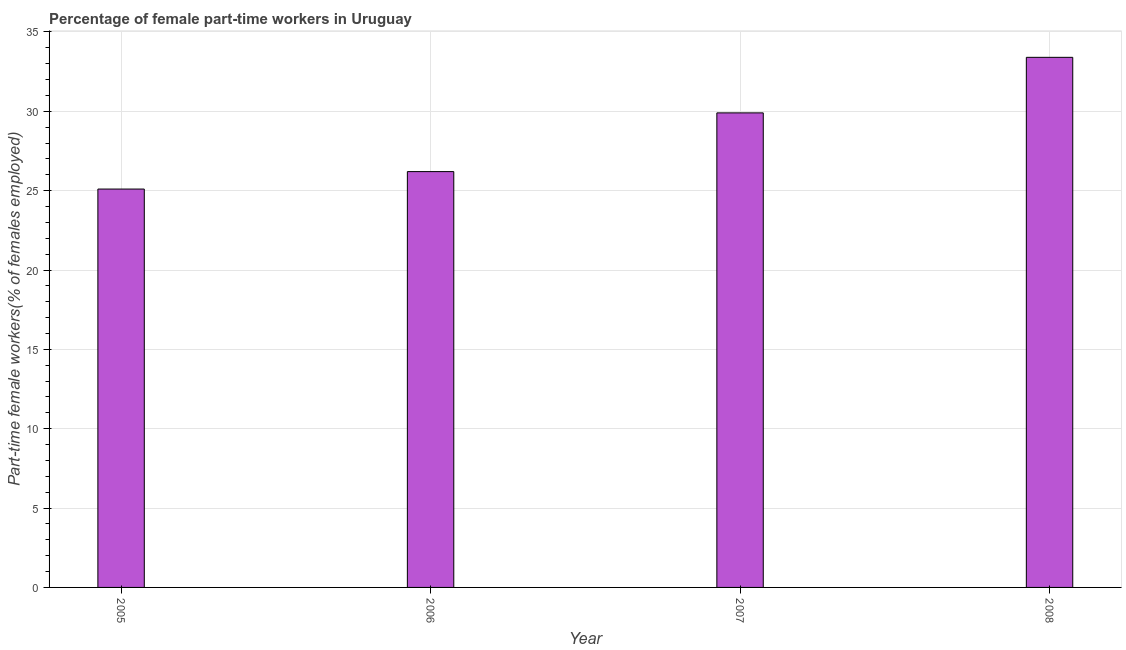What is the title of the graph?
Provide a short and direct response. Percentage of female part-time workers in Uruguay. What is the label or title of the X-axis?
Keep it short and to the point. Year. What is the label or title of the Y-axis?
Offer a terse response. Part-time female workers(% of females employed). What is the percentage of part-time female workers in 2005?
Give a very brief answer. 25.1. Across all years, what is the maximum percentage of part-time female workers?
Provide a succinct answer. 33.4. Across all years, what is the minimum percentage of part-time female workers?
Your response must be concise. 25.1. In which year was the percentage of part-time female workers minimum?
Your answer should be compact. 2005. What is the sum of the percentage of part-time female workers?
Give a very brief answer. 114.6. What is the difference between the percentage of part-time female workers in 2006 and 2007?
Offer a terse response. -3.7. What is the average percentage of part-time female workers per year?
Give a very brief answer. 28.65. What is the median percentage of part-time female workers?
Ensure brevity in your answer.  28.05. Do a majority of the years between 2008 and 2007 (inclusive) have percentage of part-time female workers greater than 11 %?
Offer a terse response. No. What is the ratio of the percentage of part-time female workers in 2007 to that in 2008?
Provide a succinct answer. 0.9. Is the percentage of part-time female workers in 2006 less than that in 2008?
Ensure brevity in your answer.  Yes. Is the sum of the percentage of part-time female workers in 2006 and 2007 greater than the maximum percentage of part-time female workers across all years?
Offer a very short reply. Yes. Are all the bars in the graph horizontal?
Keep it short and to the point. No. How many years are there in the graph?
Your answer should be compact. 4. Are the values on the major ticks of Y-axis written in scientific E-notation?
Give a very brief answer. No. What is the Part-time female workers(% of females employed) in 2005?
Give a very brief answer. 25.1. What is the Part-time female workers(% of females employed) of 2006?
Ensure brevity in your answer.  26.2. What is the Part-time female workers(% of females employed) in 2007?
Give a very brief answer. 29.9. What is the Part-time female workers(% of females employed) of 2008?
Your response must be concise. 33.4. What is the difference between the Part-time female workers(% of females employed) in 2006 and 2007?
Give a very brief answer. -3.7. What is the difference between the Part-time female workers(% of females employed) in 2006 and 2008?
Provide a short and direct response. -7.2. What is the ratio of the Part-time female workers(% of females employed) in 2005 to that in 2006?
Give a very brief answer. 0.96. What is the ratio of the Part-time female workers(% of females employed) in 2005 to that in 2007?
Ensure brevity in your answer.  0.84. What is the ratio of the Part-time female workers(% of females employed) in 2005 to that in 2008?
Keep it short and to the point. 0.75. What is the ratio of the Part-time female workers(% of females employed) in 2006 to that in 2007?
Make the answer very short. 0.88. What is the ratio of the Part-time female workers(% of females employed) in 2006 to that in 2008?
Your answer should be compact. 0.78. What is the ratio of the Part-time female workers(% of females employed) in 2007 to that in 2008?
Ensure brevity in your answer.  0.9. 